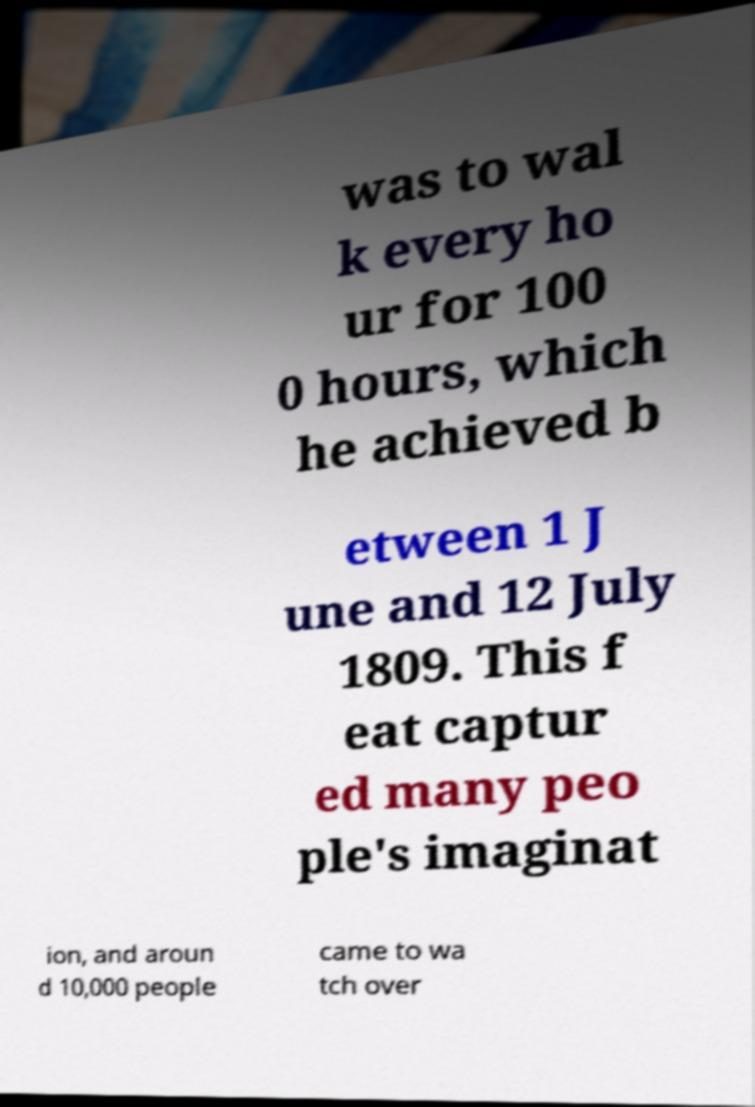What messages or text are displayed in this image? I need them in a readable, typed format. was to wal k every ho ur for 100 0 hours, which he achieved b etween 1 J une and 12 July 1809. This f eat captur ed many peo ple's imaginat ion, and aroun d 10,000 people came to wa tch over 